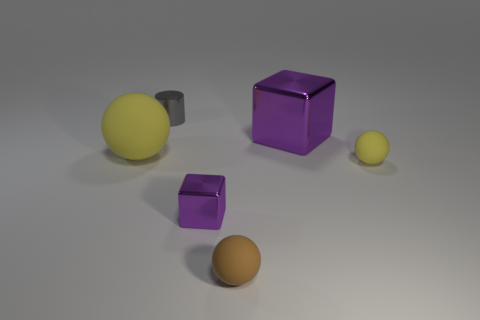Subtract all tiny balls. How many balls are left? 1 Subtract all green blocks. How many yellow balls are left? 2 Add 4 blue objects. How many objects exist? 10 Subtract all brown balls. How many balls are left? 2 Subtract 1 spheres. How many spheres are left? 2 Subtract all blocks. How many objects are left? 4 Subtract 0 yellow cylinders. How many objects are left? 6 Subtract all blue spheres. Subtract all brown blocks. How many spheres are left? 3 Subtract all tiny blue matte spheres. Subtract all big things. How many objects are left? 4 Add 2 yellow balls. How many yellow balls are left? 4 